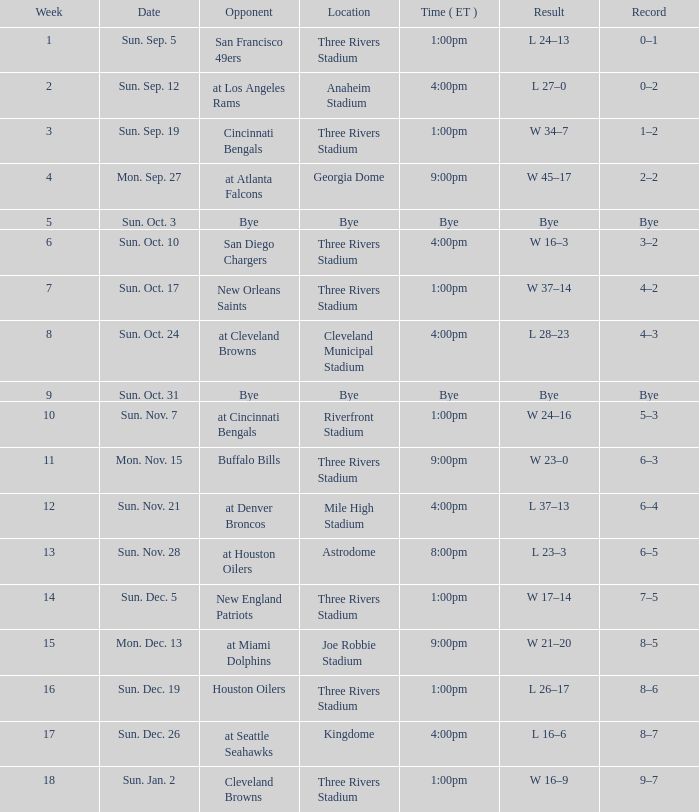What is the earliest week that shows a record of 8–5? 15.0. 